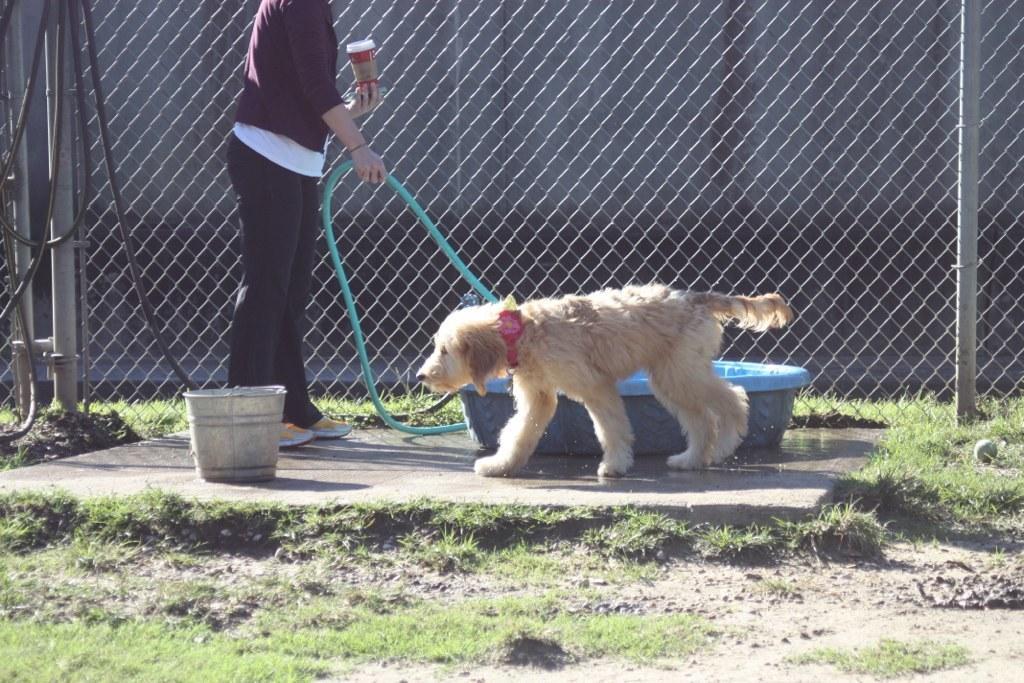Describe this image in one or two sentences. In the center of the image we can see one person is standing and she is holding a pipe and some object. And there is a fence, pipe, tub, bucket, one ball and grass. And we can see the belt around the dog's neck. 